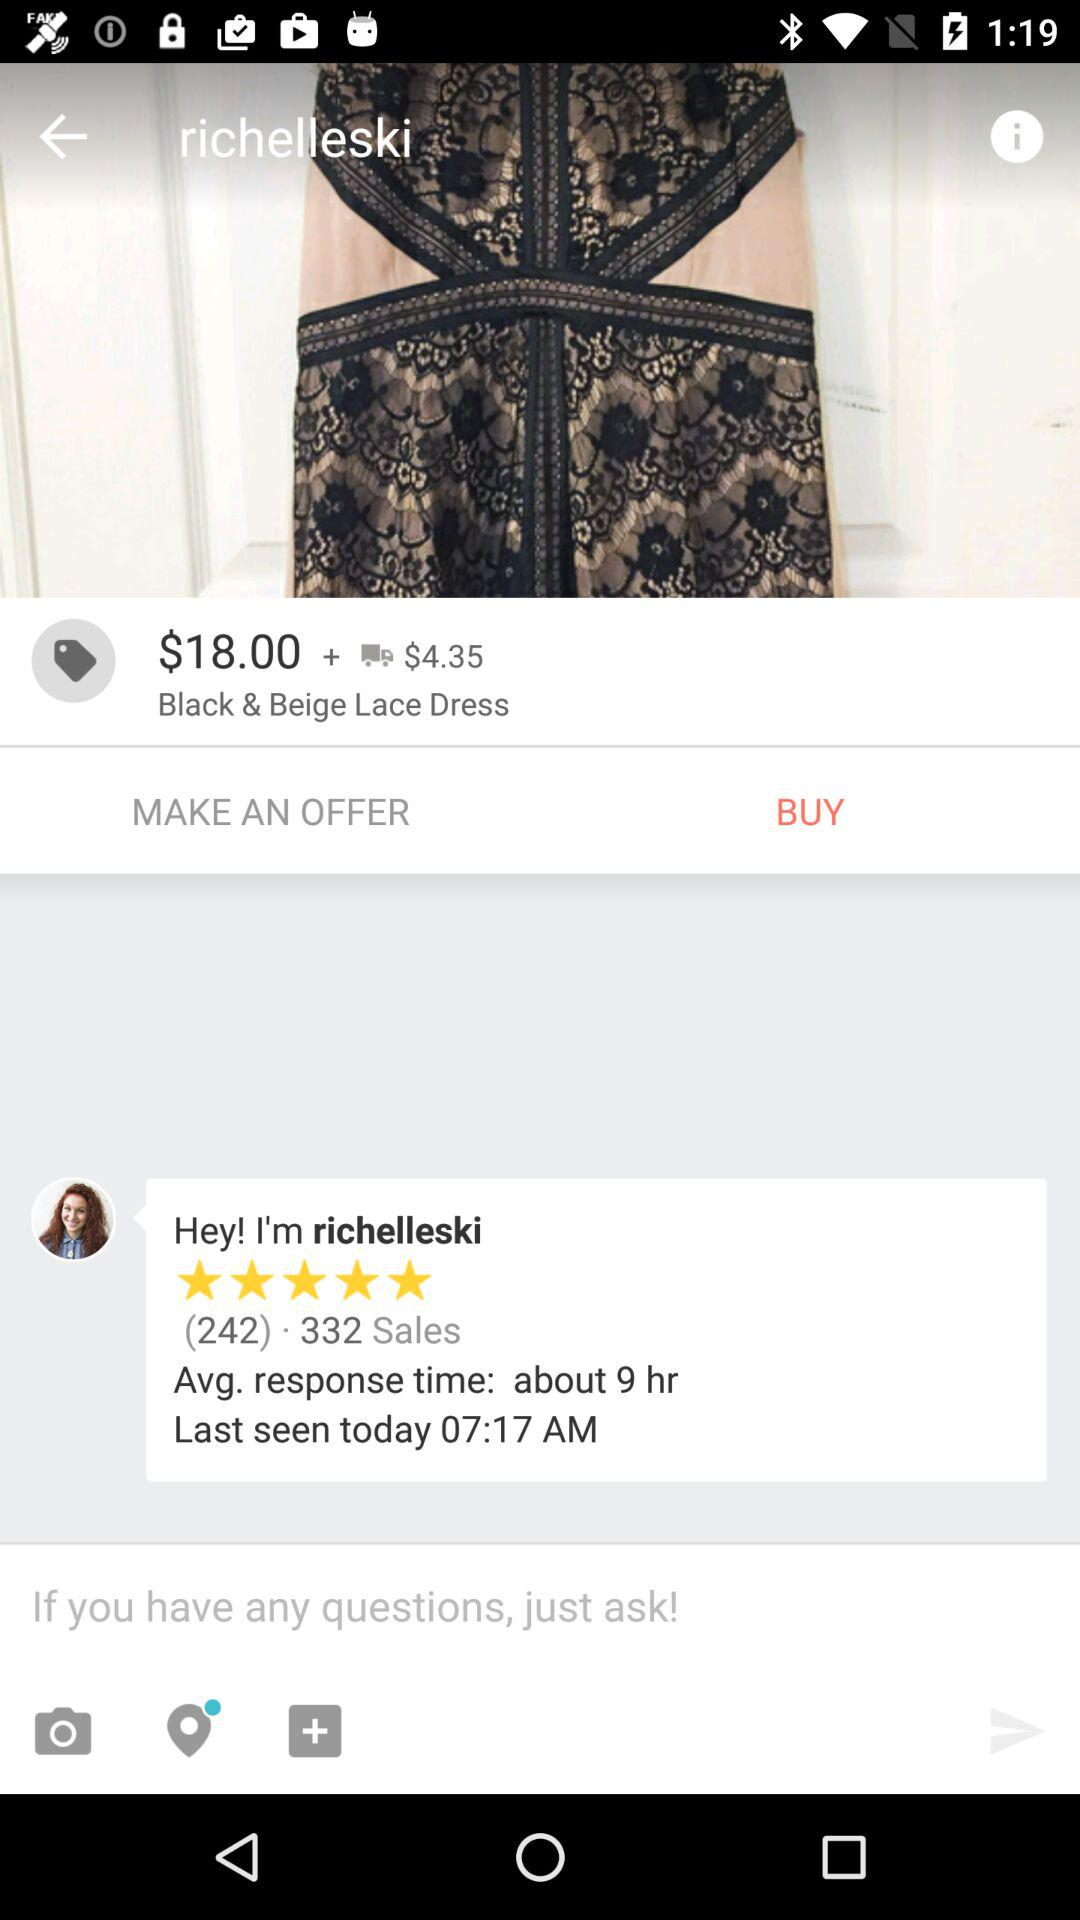What is the rating given by "richelleski"? The rating given by "richelleski" is 5 stars. 